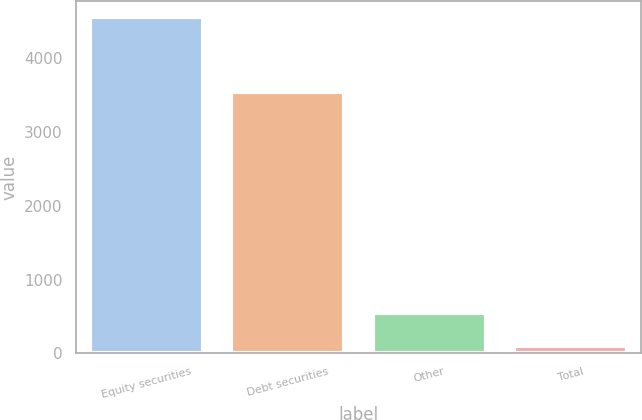Convert chart. <chart><loc_0><loc_0><loc_500><loc_500><bar_chart><fcel>Equity securities<fcel>Debt securities<fcel>Other<fcel>Total<nl><fcel>4555<fcel>3545<fcel>545.5<fcel>100<nl></chart> 